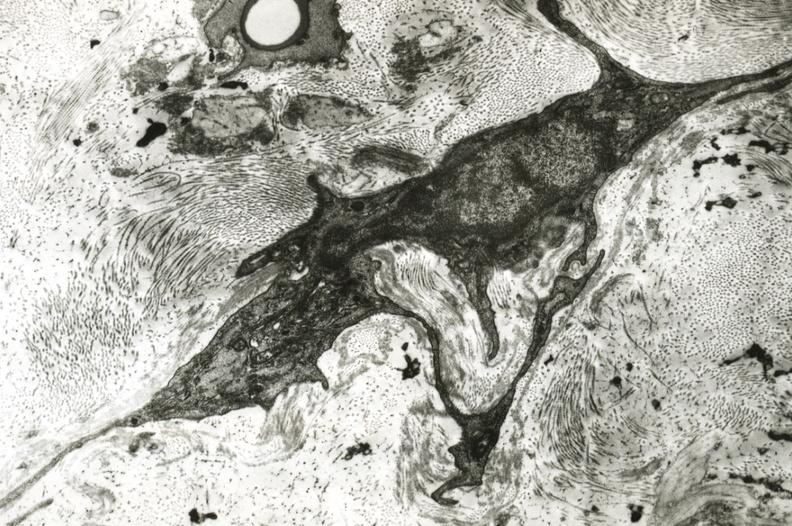what is present?
Answer the question using a single word or phrase. Cranial artery 